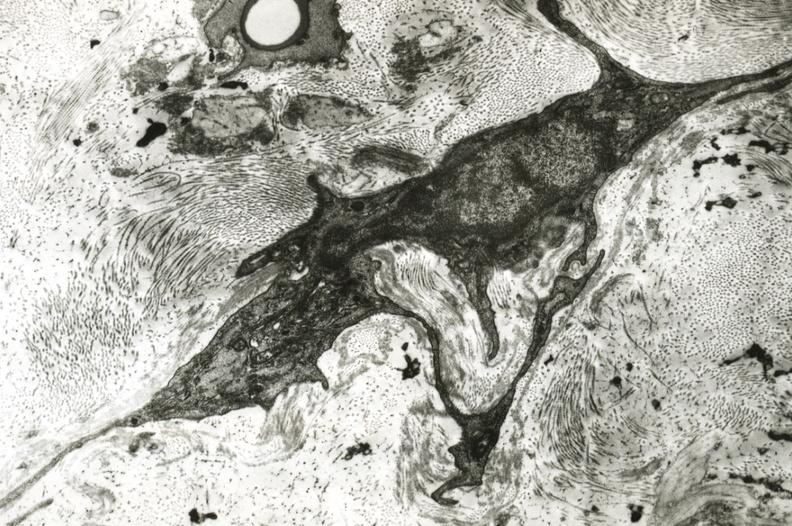what is present?
Answer the question using a single word or phrase. Cranial artery 